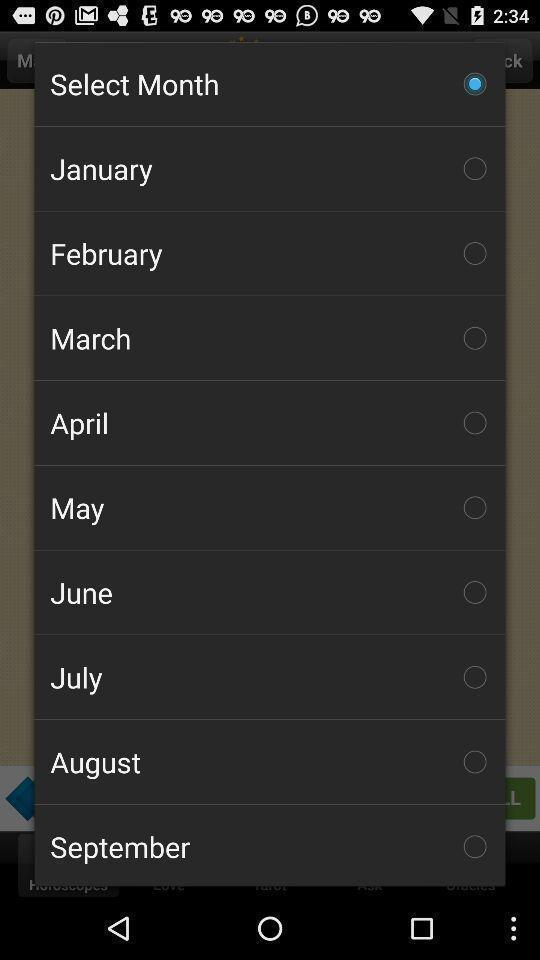Describe this image in words. Pop-up showing to select a month. 